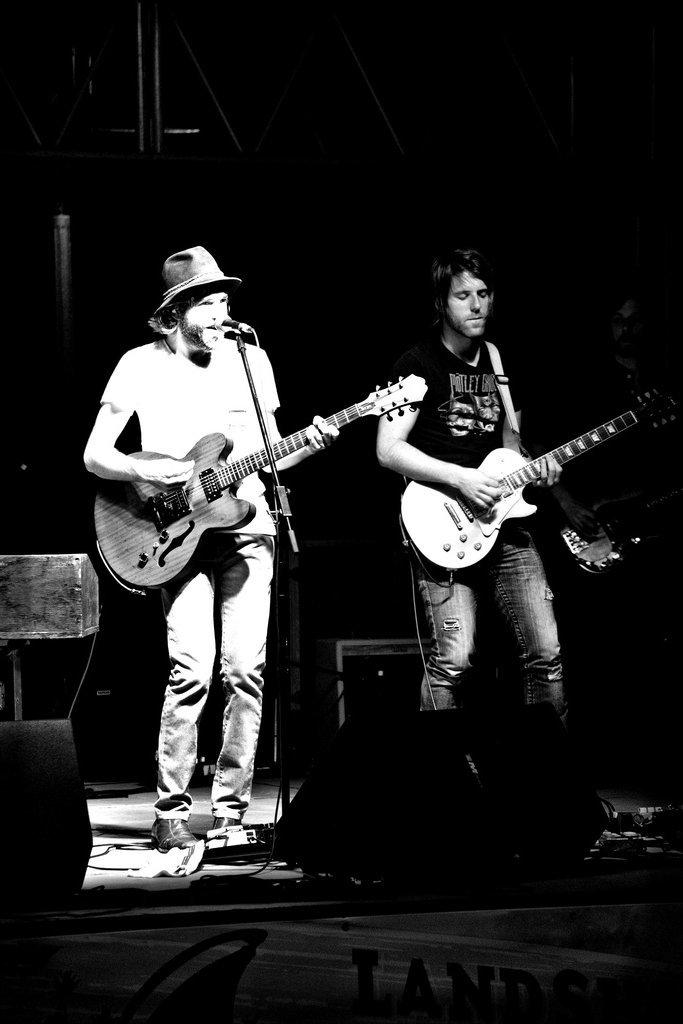How many people are in the image? There are two people in the image. What are the two people doing in the image? The two people are playing the guitar. Where are the guitar players located in the image? The guitar players are on a stage. What can be seen at the center of the image? There is a microphone and a speaker at the center of the image. What type of vest is the square wearing in the image? There is no square or vest present in the image. What is the opinion of the speaker about the guitar players in the image? There is no indication of anyone's opinion in the image, as it only shows two guitar players on a stage with a microphone and a speaker. 